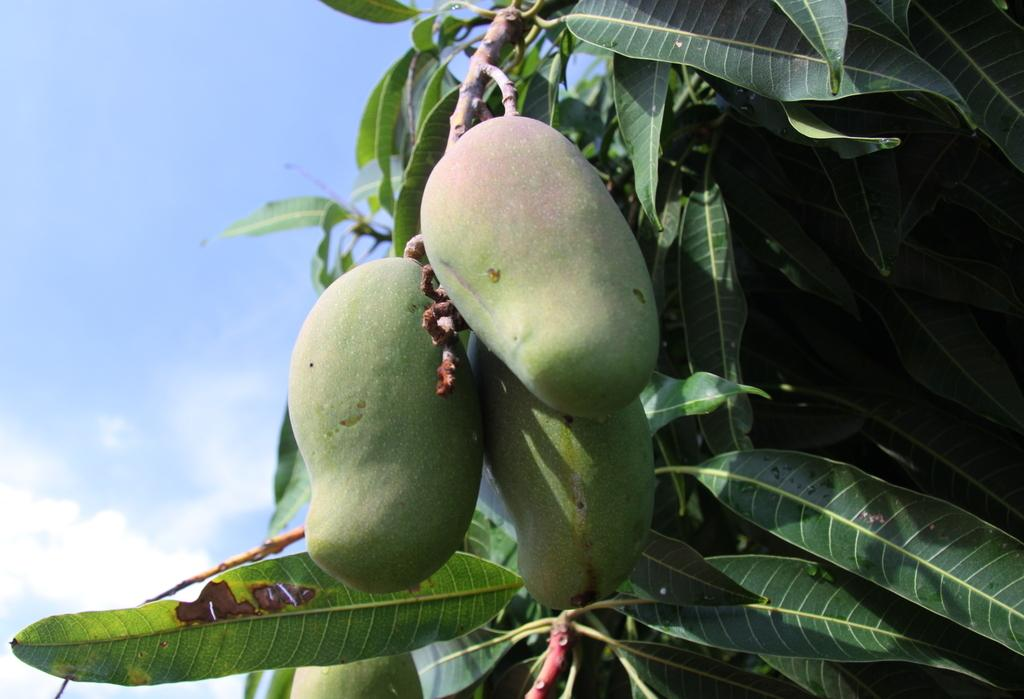What type of plant can be seen in the image? There is a tree in the image. What fruit is growing on the tree? There are mangoes on the tree. How would you describe the sky in the image? The sky is blue and slightly cloudy in the image. What type of transport is visible in the image? There is no transport visible in the image; it only features a tree with mangoes and a blue, slightly cloudy sky. Can you identify any diseases affecting the tree in the image? There is no indication of any diseases affecting the tree in the image. 